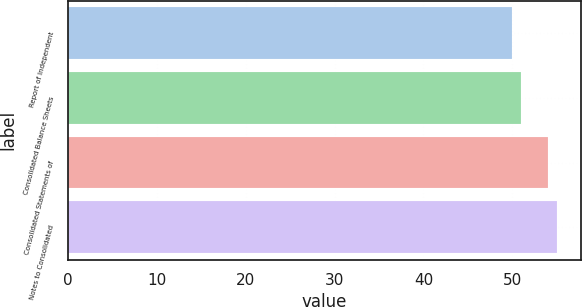Convert chart. <chart><loc_0><loc_0><loc_500><loc_500><bar_chart><fcel>Report of Independent<fcel>Consolidated Balance Sheets<fcel>Consolidated Statements of<fcel>Notes to Consolidated<nl><fcel>50<fcel>51<fcel>54<fcel>55<nl></chart> 